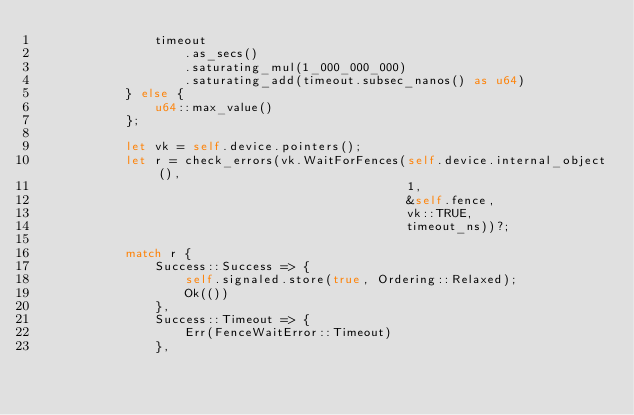<code> <loc_0><loc_0><loc_500><loc_500><_Rust_>                timeout
                    .as_secs()
                    .saturating_mul(1_000_000_000)
                    .saturating_add(timeout.subsec_nanos() as u64)
            } else {
                u64::max_value()
            };

            let vk = self.device.pointers();
            let r = check_errors(vk.WaitForFences(self.device.internal_object(),
                                                  1,
                                                  &self.fence,
                                                  vk::TRUE,
                                                  timeout_ns))?;

            match r {
                Success::Success => {
                    self.signaled.store(true, Ordering::Relaxed);
                    Ok(())
                },
                Success::Timeout => {
                    Err(FenceWaitError::Timeout)
                },</code> 